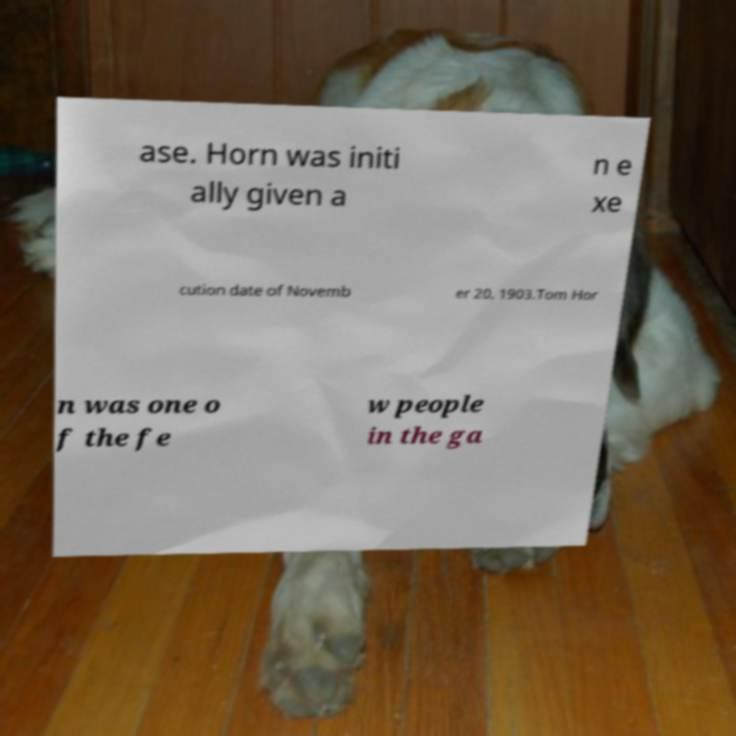For documentation purposes, I need the text within this image transcribed. Could you provide that? ase. Horn was initi ally given a n e xe cution date of Novemb er 20, 1903.Tom Hor n was one o f the fe w people in the ga 